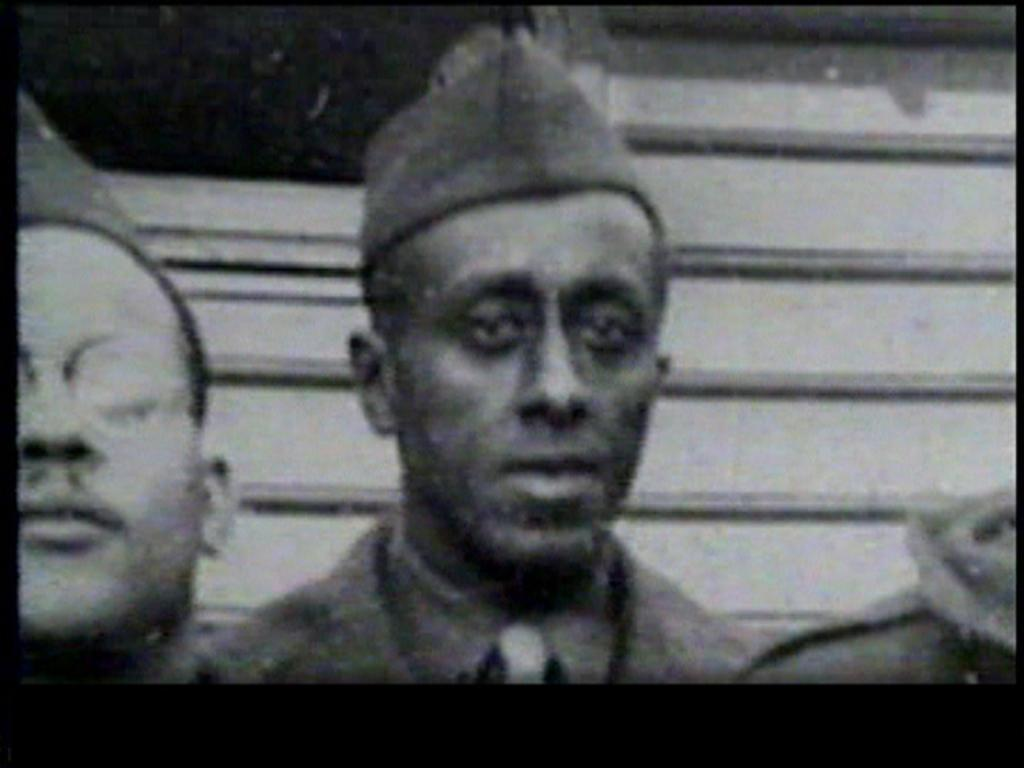What is the color scheme of the image? The image is black and white. Can you describe the person in the center of the image? The person in the center of the image is wearing a cap. What can be seen on the person on the left side of the image? The person on the left side of the image is wearing spectacles. How many eyes does the tiger have in the image? There is no tiger present in the image. What is the wealth status of the person in the center of the image? The image does not provide any information about the wealth status of the person in the center of the image. 